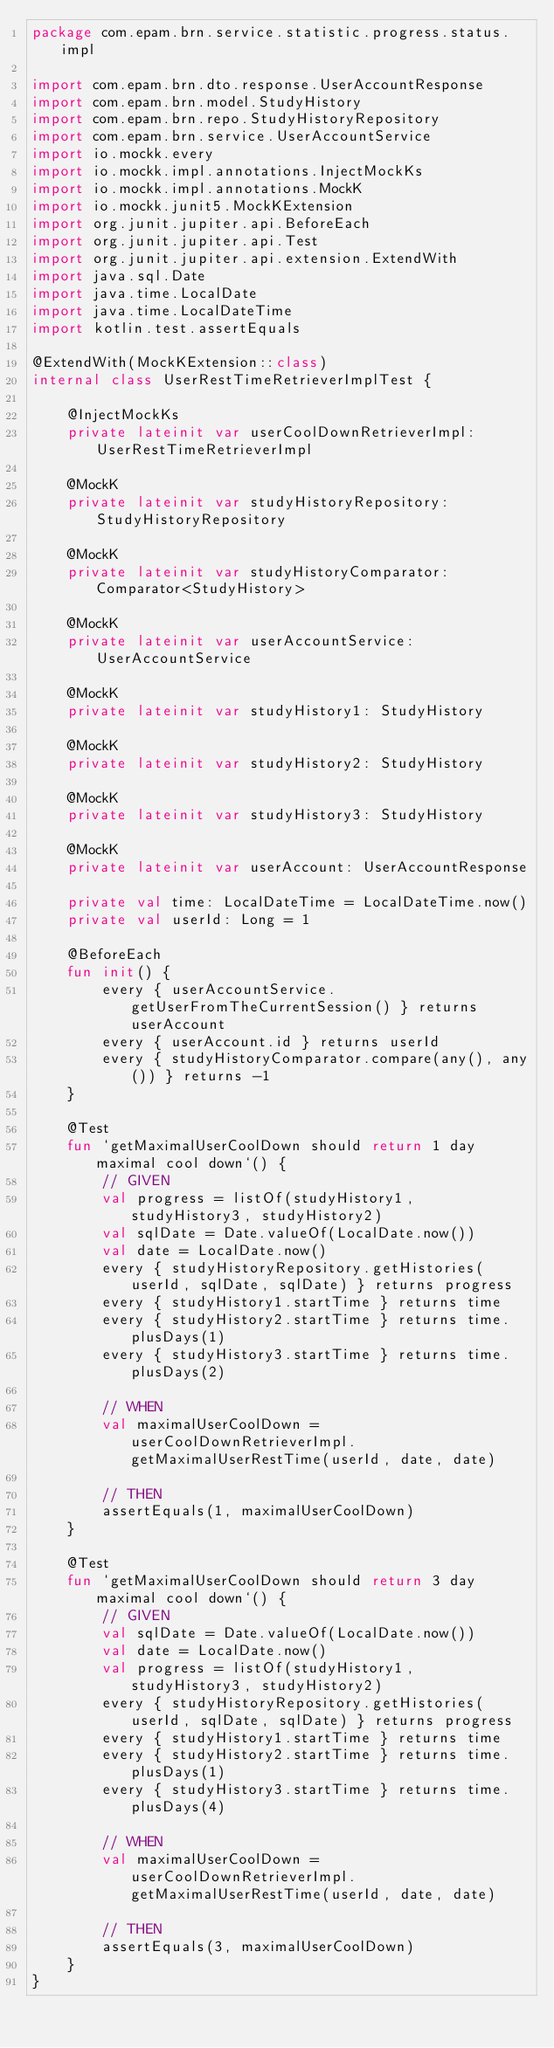Convert code to text. <code><loc_0><loc_0><loc_500><loc_500><_Kotlin_>package com.epam.brn.service.statistic.progress.status.impl

import com.epam.brn.dto.response.UserAccountResponse
import com.epam.brn.model.StudyHistory
import com.epam.brn.repo.StudyHistoryRepository
import com.epam.brn.service.UserAccountService
import io.mockk.every
import io.mockk.impl.annotations.InjectMockKs
import io.mockk.impl.annotations.MockK
import io.mockk.junit5.MockKExtension
import org.junit.jupiter.api.BeforeEach
import org.junit.jupiter.api.Test
import org.junit.jupiter.api.extension.ExtendWith
import java.sql.Date
import java.time.LocalDate
import java.time.LocalDateTime
import kotlin.test.assertEquals

@ExtendWith(MockKExtension::class)
internal class UserRestTimeRetrieverImplTest {

    @InjectMockKs
    private lateinit var userCoolDownRetrieverImpl: UserRestTimeRetrieverImpl

    @MockK
    private lateinit var studyHistoryRepository: StudyHistoryRepository

    @MockK
    private lateinit var studyHistoryComparator: Comparator<StudyHistory>

    @MockK
    private lateinit var userAccountService: UserAccountService

    @MockK
    private lateinit var studyHistory1: StudyHistory

    @MockK
    private lateinit var studyHistory2: StudyHistory

    @MockK
    private lateinit var studyHistory3: StudyHistory

    @MockK
    private lateinit var userAccount: UserAccountResponse

    private val time: LocalDateTime = LocalDateTime.now()
    private val userId: Long = 1

    @BeforeEach
    fun init() {
        every { userAccountService.getUserFromTheCurrentSession() } returns userAccount
        every { userAccount.id } returns userId
        every { studyHistoryComparator.compare(any(), any()) } returns -1
    }

    @Test
    fun `getMaximalUserCoolDown should return 1 day maximal cool down`() {
        // GIVEN
        val progress = listOf(studyHistory1, studyHistory3, studyHistory2)
        val sqlDate = Date.valueOf(LocalDate.now())
        val date = LocalDate.now()
        every { studyHistoryRepository.getHistories(userId, sqlDate, sqlDate) } returns progress
        every { studyHistory1.startTime } returns time
        every { studyHistory2.startTime } returns time.plusDays(1)
        every { studyHistory3.startTime } returns time.plusDays(2)

        // WHEN
        val maximalUserCoolDown = userCoolDownRetrieverImpl.getMaximalUserRestTime(userId, date, date)

        // THEN
        assertEquals(1, maximalUserCoolDown)
    }

    @Test
    fun `getMaximalUserCoolDown should return 3 day maximal cool down`() {
        // GIVEN
        val sqlDate = Date.valueOf(LocalDate.now())
        val date = LocalDate.now()
        val progress = listOf(studyHistory1, studyHistory3, studyHistory2)
        every { studyHistoryRepository.getHistories(userId, sqlDate, sqlDate) } returns progress
        every { studyHistory1.startTime } returns time
        every { studyHistory2.startTime } returns time.plusDays(1)
        every { studyHistory3.startTime } returns time.plusDays(4)

        // WHEN
        val maximalUserCoolDown = userCoolDownRetrieverImpl.getMaximalUserRestTime(userId, date, date)

        // THEN
        assertEquals(3, maximalUserCoolDown)
    }
}
</code> 